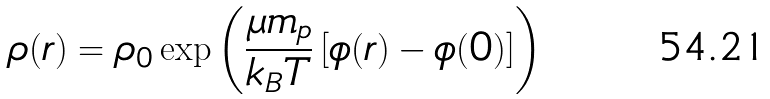Convert formula to latex. <formula><loc_0><loc_0><loc_500><loc_500>\rho ( r ) = \rho _ { 0 } \exp \left ( { \frac { \mu m _ { p } } { k _ { B } T } } \left [ \phi ( r ) - \phi ( 0 ) \right ] \right )</formula> 